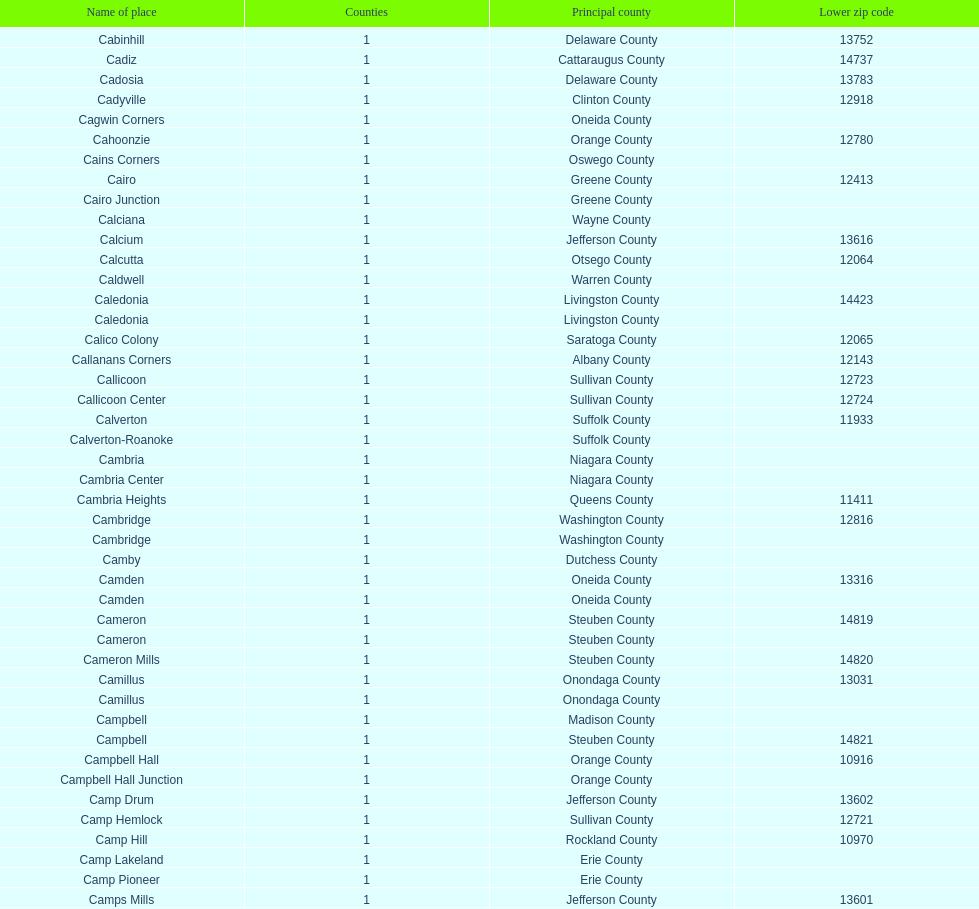Which county is listed above calciana? Cairo Junction. 